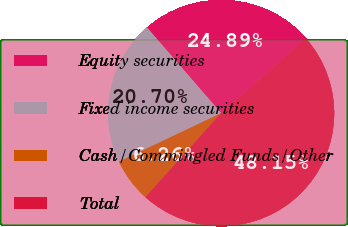Convert chart to OTSL. <chart><loc_0><loc_0><loc_500><loc_500><pie_chart><fcel>Equity securities<fcel>Fixed income securities<fcel>Cash/Commingled Funds/Other<fcel>Total<nl><fcel>24.89%<fcel>20.7%<fcel>6.26%<fcel>48.15%<nl></chart> 